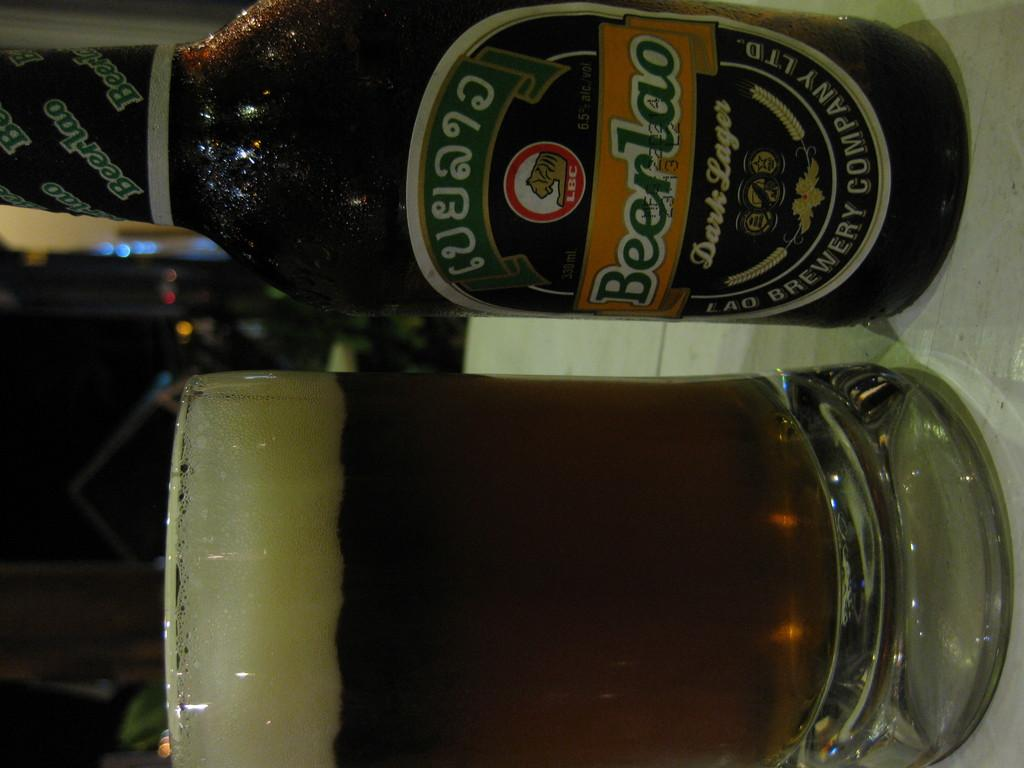<image>
Summarize the visual content of the image. A bottle of Beerlao dark lager is placed next to a beer mug. 